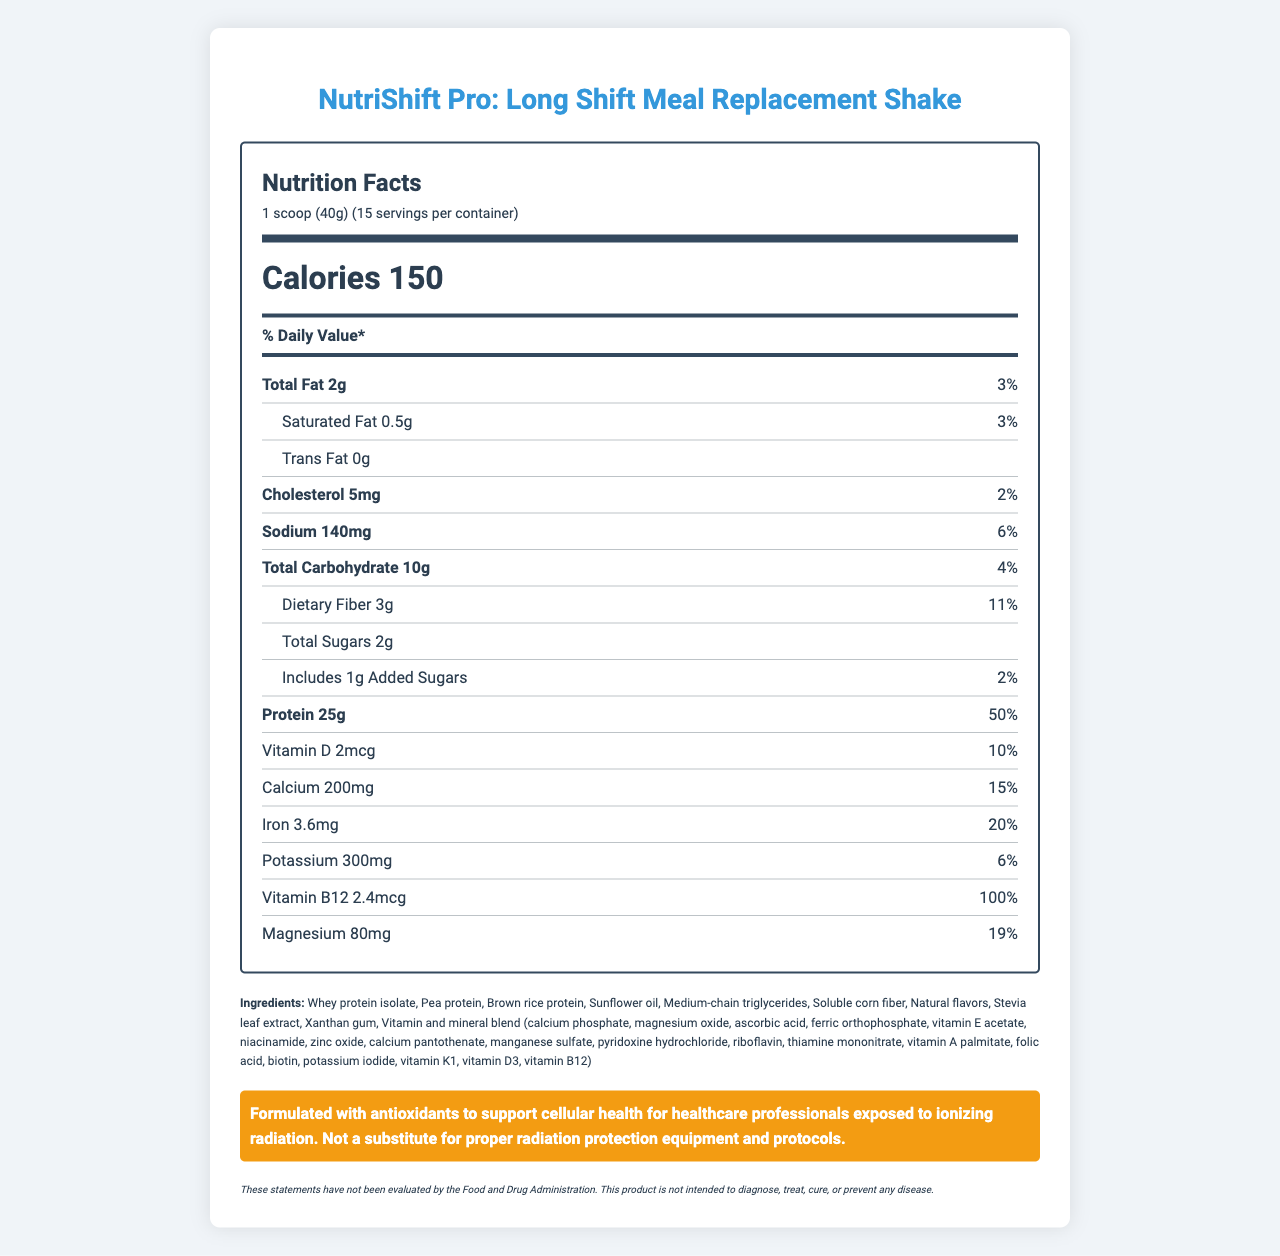what is the serving size? The document mentions the serving size at the top under the "Nutrition Facts" section.
Answer: 1 scoop (40g) how many servings does each container provide? The document lists this information as "15 servings per container".
Answer: 15 what is the calorie count per serving? The document specifies that each serving contains 150 calories.
Answer: 150 how much protein is in a serving? The protein content per serving is listed as 25g in the document.
Answer: 25g what percentage of daily value of protein does one serving provide? The document states that the daily value percentage for protein is 50%.
Answer: 50% what is the total fat content per serving? The document states that each serving contains 2g of total fat.
Answer: 2g what is the daily value percentage of saturated fat? The daily value percentage for saturated fat is listed as 3% in the document.
Answer: 3% how much dietary fiber is in a serving? The document states that each serving contains 3g of dietary fiber.
Answer: 3g how much cholesterol is in a serving? The amount of cholesterol per serving is listed as 5mg in the document.
Answer: 5mg what is the sugar content per serving? The document specifies that there are 2g of total sugars per serving.
Answer: 2g which of the following ingredients is not included in the product? A. Whey protein isolate B. Aspartame C. Xanthan gum D. Stevia leaf extract Aspartame is not listed in the ingredients.
Answer: B how much vitamin B12 is provided per serving? A. 1mcg B. 2.4mcg C. 5mcg D. 1.5mcg The document states that each serving provides 2.4mcg of vitamin B12.
Answer: B does the product contain any trans fat? The document specifies that there is 0g of trans fat per serving.
Answer: No is the product intended to diagnose, treat, cure, or prevent any disease? The disclaimer at the bottom of the document states that the product is not intended to diagnose, treat, cure, or prevent any disease.
Answer: No briefly summarize the main information provided in the document. The document outlines the nutrition facts, ingredients, and specific notes relevant to healthcare professionals for the NutriShift Pro meal replacement shake, emphasizing its high protein content and safety.
Answer: The document provides nutrition facts for NutriShift Pro: Long Shift Meal Replacement Shake designed for healthcare professionals. It includes detailed information on serving size, number of servings, calories, and nutrient content by serving. It also outlines the ingredients, allergen information, a radiation safety note emphasizing the importance of antioxidants for cellular health, and a disclaimer regarding disease diagnosis and treatment. what is the manufacturing address of the product? The document lists the manufacturer's address as "123 Medical Center Dr., Boston, MA 02115".
Answer: 123 Medical Center Dr., Boston, MA 02115 how can the shake be prepared? The document provides specific directions for preparing the shake in the "directions" section.
Answer: Mix 1 scoop (40g) with 8-10 oz of cold water or unsweetened almond milk. Shake well and consume within 30 minutes of preparation. how much magnesium is in each serving of the product? The document lists the magnesium content per serving as 80mg.
Answer: 80mg can this product substitute proper radiation protection equipment and protocols? The radiation safety note specifies that it is not a substitute for proper radiation protection equipment and protocols.
Answer: No 